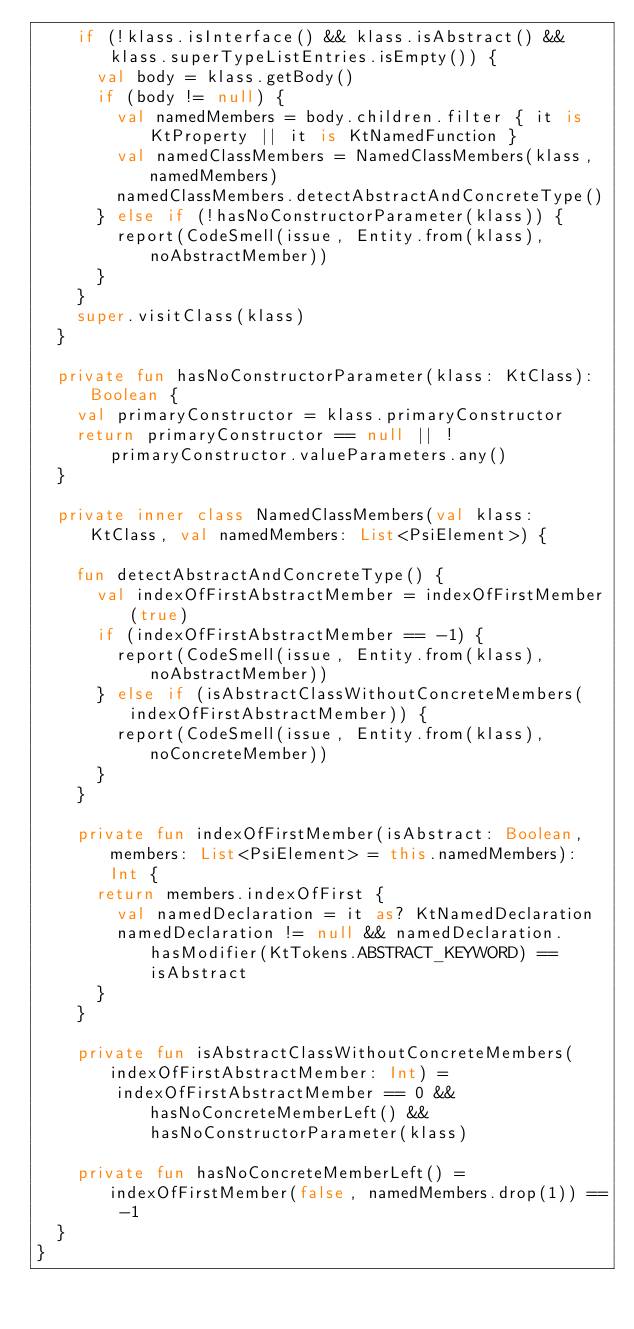Convert code to text. <code><loc_0><loc_0><loc_500><loc_500><_Kotlin_>		if (!klass.isInterface() && klass.isAbstract() && klass.superTypeListEntries.isEmpty()) {
			val body = klass.getBody()
			if (body != null) {
				val namedMembers = body.children.filter { it is KtProperty || it is KtNamedFunction }
				val namedClassMembers = NamedClassMembers(klass, namedMembers)
				namedClassMembers.detectAbstractAndConcreteType()
			} else if (!hasNoConstructorParameter(klass)) {
				report(CodeSmell(issue, Entity.from(klass), noAbstractMember))
			}
		}
		super.visitClass(klass)
	}

	private fun hasNoConstructorParameter(klass: KtClass): Boolean {
		val primaryConstructor = klass.primaryConstructor
		return primaryConstructor == null || !primaryConstructor.valueParameters.any()
	}

	private inner class NamedClassMembers(val klass: KtClass, val namedMembers: List<PsiElement>) {

		fun detectAbstractAndConcreteType() {
			val indexOfFirstAbstractMember = indexOfFirstMember(true)
			if (indexOfFirstAbstractMember == -1) {
				report(CodeSmell(issue, Entity.from(klass), noAbstractMember))
			} else if (isAbstractClassWithoutConcreteMembers(indexOfFirstAbstractMember)) {
				report(CodeSmell(issue, Entity.from(klass), noConcreteMember))
			}
		}

		private fun indexOfFirstMember(isAbstract: Boolean, members: List<PsiElement> = this.namedMembers): Int {
			return members.indexOfFirst {
				val namedDeclaration = it as? KtNamedDeclaration
				namedDeclaration != null && namedDeclaration.hasModifier(KtTokens.ABSTRACT_KEYWORD) == isAbstract
			}
		}

		private fun isAbstractClassWithoutConcreteMembers(indexOfFirstAbstractMember: Int) =
				indexOfFirstAbstractMember == 0 && hasNoConcreteMemberLeft() && hasNoConstructorParameter(klass)

		private fun hasNoConcreteMemberLeft() = indexOfFirstMember(false, namedMembers.drop(1)) == -1
	}
}
</code> 